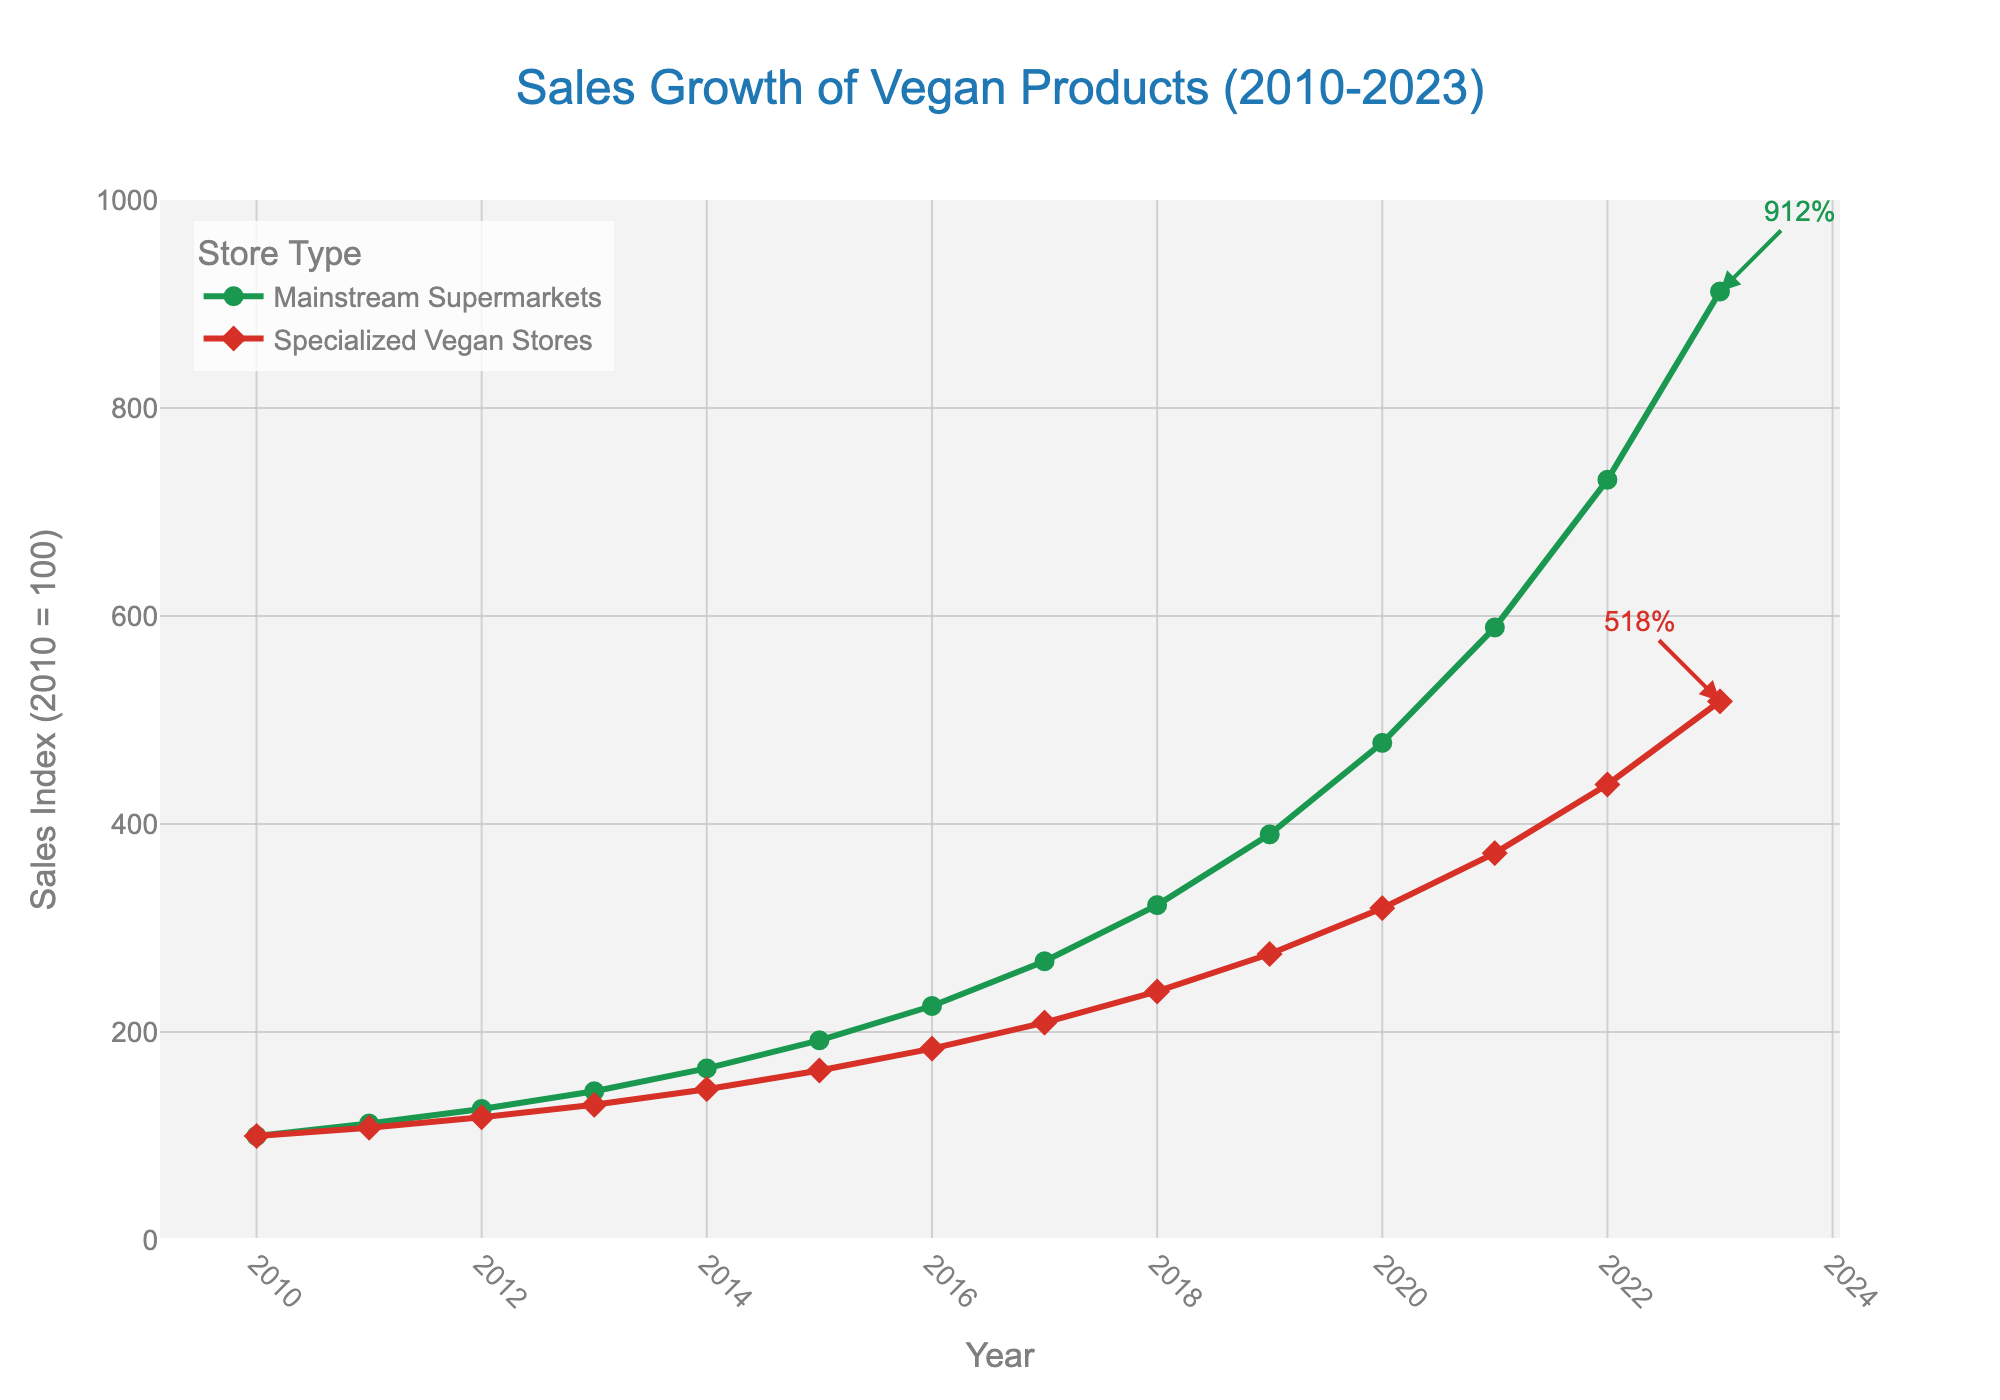What is the sales growth index for mainstream supermarkets in 2020? The sales growth index for mainstream supermarkets in 2020 is found at the intersection of the 2020 marker on the x-axis and the green line representing mainstream supermarkets. According to the chart, the value is 478.
Answer: 478 Which type of store had higher sales growth in 2012? To determine which store had a higher sales growth, compare the indices for both store types in 2012. The index for mainstream supermarkets is 126, and for specialized vegan stores, it is 118. Since 126 > 118, mainstream supermarkets had higher sales growth in 2012.
Answer: Mainstream supermarkets What was the difference in the sales growth index between mainstream supermarkets and specialized vegan stores in 2023? Subtract the sales growth index of specialized vegan stores (518) from that of mainstream supermarkets (912). 912 - 518 = 394.
Answer: 394 Calculate the average sales growth index for mainstream supermarkets from 2010 to 2023. Sum up the sales growth values for mainstream supermarkets for each year and divide by the number of years (14). (100 + 112 + 126 + 143 + 165 + 192 + 225 + 268 + 322 + 390 + 478 + 589 + 731 + 912)/14 = 3220/14 = 551.43
Answer: 551.43 At what year did the sales growth index for mainstream supermarkets significantly surpass 500? Locate the point where the green line representing mainstream supermarkets significantly passes the 500 mark on the y-axis. This happens between 2020 (478) and 2021 (589). Therefore, the year is 2021.
Answer: 2021 What color represents the sales growth of specialized vegan stores? The color representing specialized vegan stores is the same as the line color used in the figure for specialized vegan stores, which is red.
Answer: Red How many times higher was the sales index for mainstream supermarkets in 2023 compared to 2010? To find this, we take the sales growth index of mainstream supermarkets in 2023 (912) and divide it by the index in 2010 (100). 912 / 100 = 9.12.
Answer: 9.12 Calculate the combined sales growth indexes for both mainstream supermarkets and specialized vegan stores in 2015. To combine the sales growth indexes, add the values for both store types for the year 2015. For mainstream supermarkets, it is 192, and for specialized vegan stores, it is 163. 192 + 163 = 355.
Answer: 355 Which year saw the most substantial increase in sales growth for specialized vegan stores? To determine the year with the most significant increase, examine the year-over-year changes in the red line that represents specialized vegan stores. The most substantial increase is between 2021 (372) and 2022 (438). The increase is 438 - 372 = 66.
Answer: 2022 